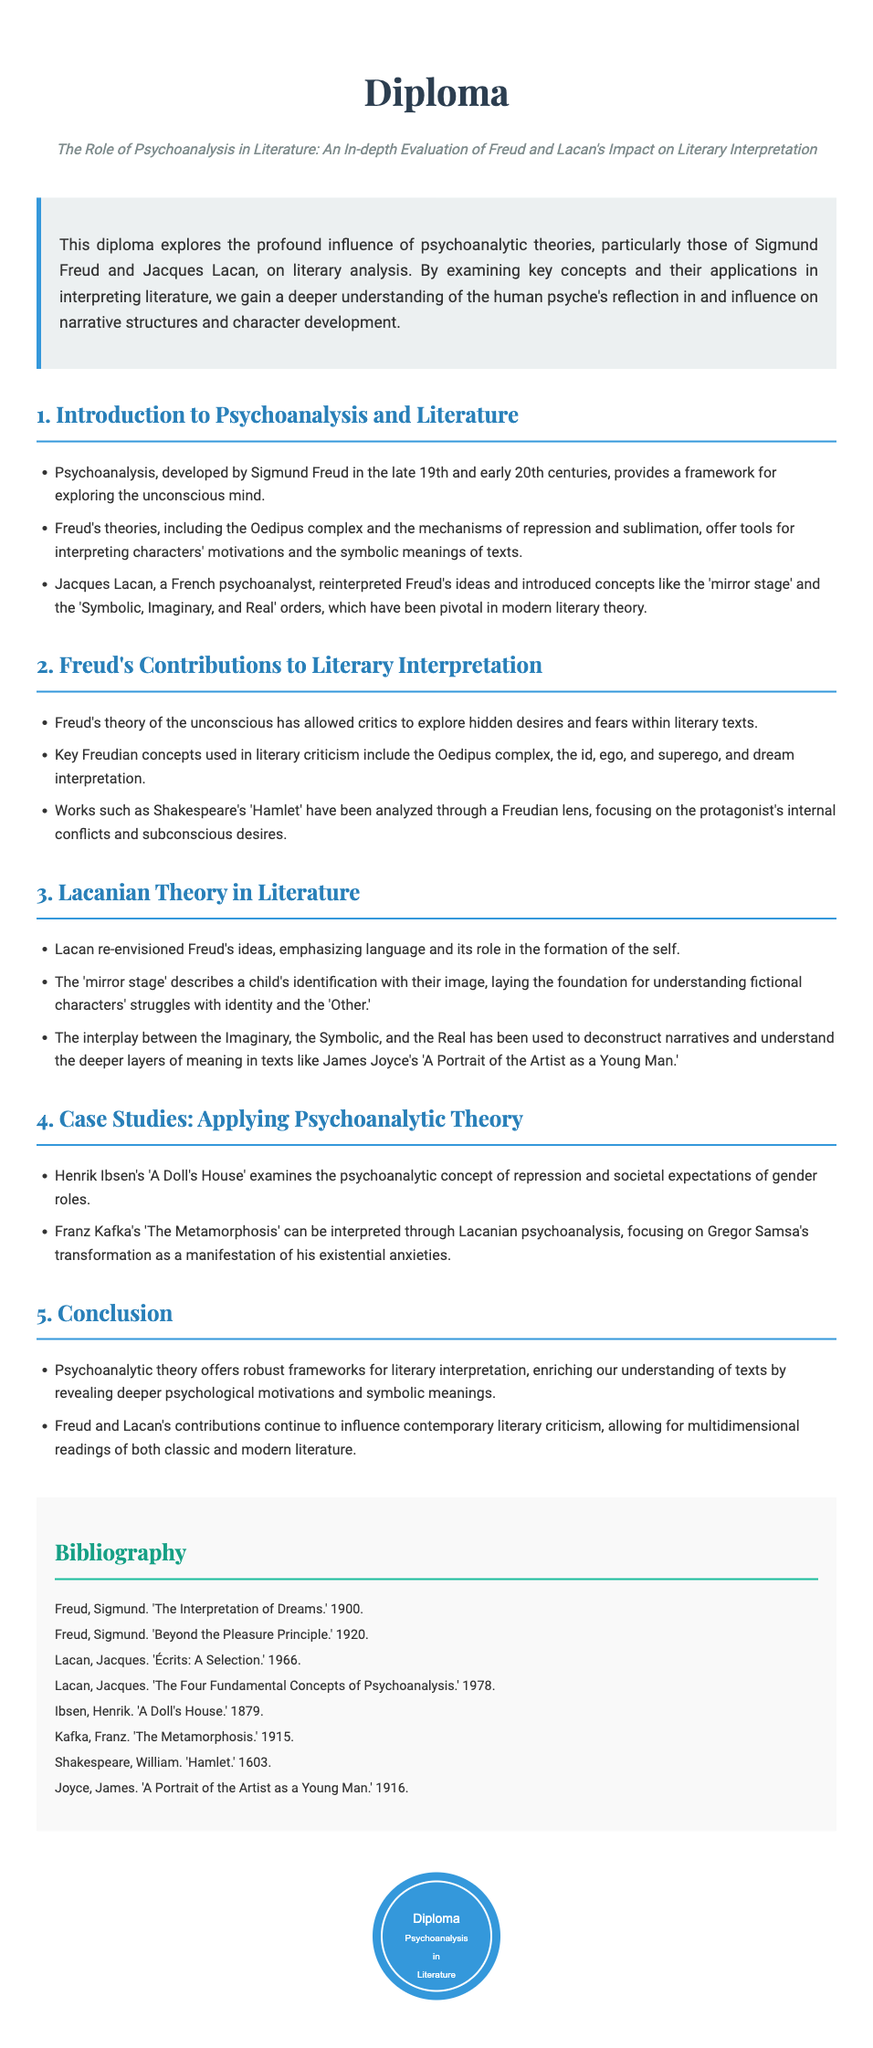What is the title of the diploma? The title of the diploma is clearly stated in the header section as it summarizes the main theme of the document.
Answer: The Role of Psychoanalysis in Literature: An In-depth Evaluation of Freud and Lacan's Impact on Literary Interpretation Who developed psychoanalysis? The document mentions Sigmund Freud as the developer of psychoanalysis in the introduction section.
Answer: Sigmund Freud What year was 'A Doll's House' published? The bibliography lists the publication year of 'A Doll's House,' providing a specific date associated with the work.
Answer: 1879 What is one of Freud's key concepts used in literary criticism? The section on Freud’s contributions indicates specific theories that are utilized for literary interpretation.
Answer: Oedipus complex Which author's work is analyzed through a Lacanian lens according to the document? The case studies section highlights literature that has been examined through Lacanian theory, showcasing specific authors.
Answer: Franz Kafka What is the main focus of Lacan's re-envisioning of Freud's ideas? The document emphasizes the shift in focus introduced by Lacan, which is critical to understanding his influence on literature.
Answer: Language How many sections are there in the diploma? By counting the main headings, one can determine the overall structure of the diploma and how it is divided into sections.
Answer: Five What is the bibliographic year of 'The Interpretation of Dreams'? The specific bibliographic information directly provides the publication year, which is listed in the references.
Answer: 1900 